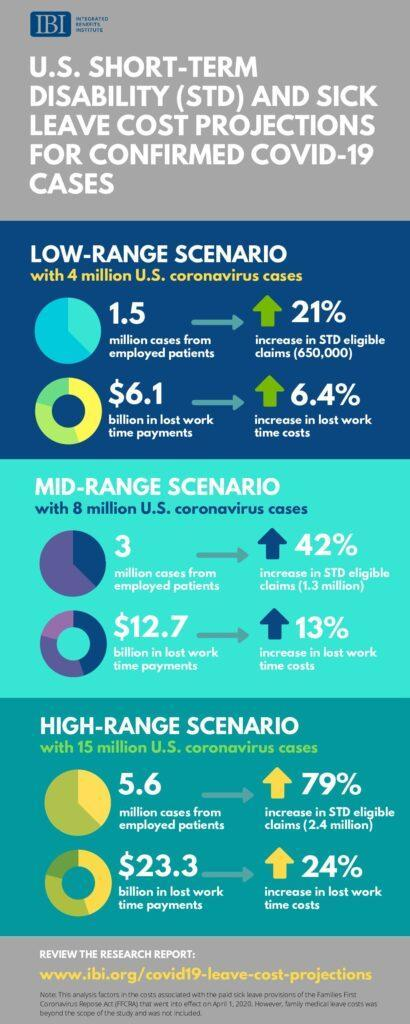What is the difference between employed patients cases in the mid-range and low-range scenarios?
Answer the question with a short phrase. 1.5 How many scenarios are in this infographic? 3 What is the difference between employed patients cases in the high-range and mid-range scenarios? 2.6 